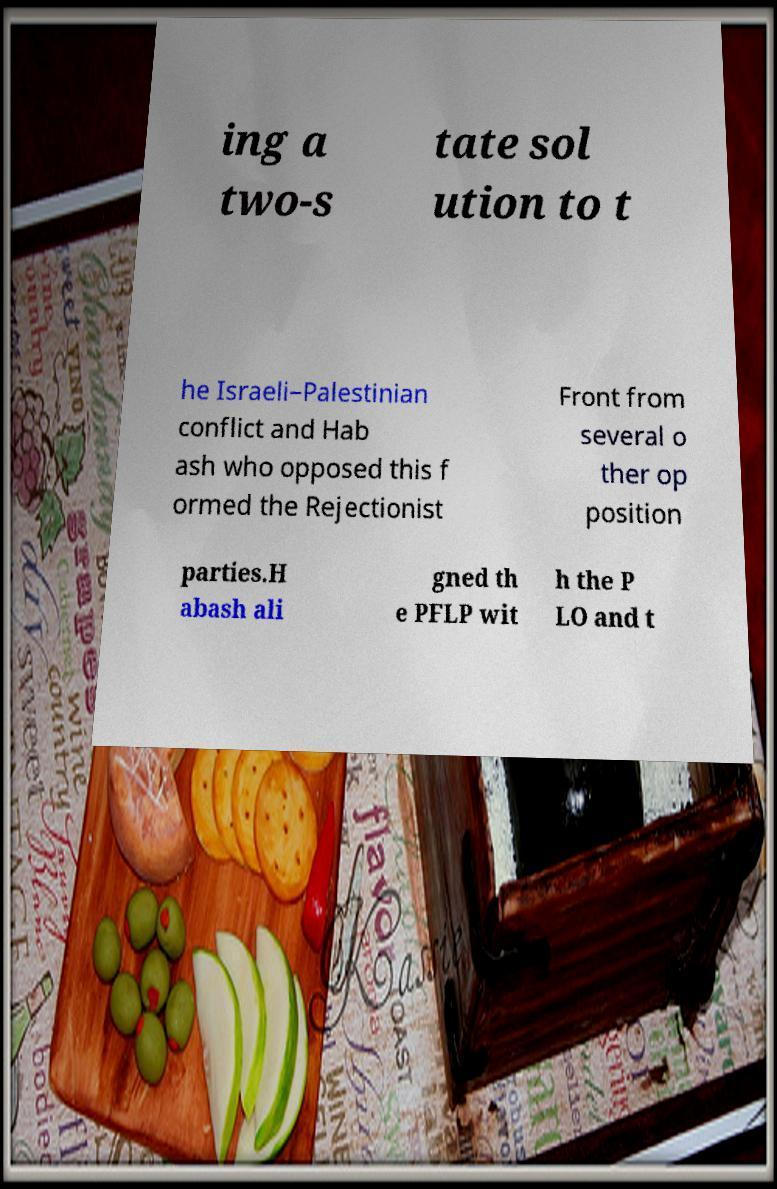Can you accurately transcribe the text from the provided image for me? ing a two-s tate sol ution to t he Israeli–Palestinian conflict and Hab ash who opposed this f ormed the Rejectionist Front from several o ther op position parties.H abash ali gned th e PFLP wit h the P LO and t 